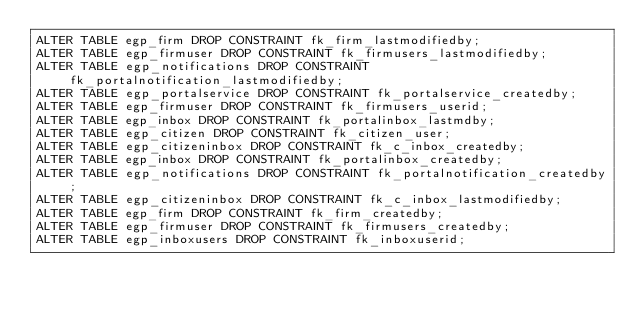Convert code to text. <code><loc_0><loc_0><loc_500><loc_500><_SQL_>ALTER TABLE egp_firm DROP CONSTRAINT fk_firm_lastmodifiedby;
ALTER TABLE egp_firmuser DROP CONSTRAINT fk_firmusers_lastmodifiedby;
ALTER TABLE egp_notifications DROP CONSTRAINT fk_portalnotification_lastmodifiedby;
ALTER TABLE egp_portalservice DROP CONSTRAINT fk_portalservice_createdby;
ALTER TABLE egp_firmuser DROP CONSTRAINT fk_firmusers_userid;
ALTER TABLE egp_inbox DROP CONSTRAINT fk_portalinbox_lastmdby;
ALTER TABLE egp_citizen DROP CONSTRAINT fk_citizen_user;
ALTER TABLE egp_citizeninbox DROP CONSTRAINT fk_c_inbox_createdby;
ALTER TABLE egp_inbox DROP CONSTRAINT fk_portalinbox_createdby;
ALTER TABLE egp_notifications DROP CONSTRAINT fk_portalnotification_createdby;
ALTER TABLE egp_citizeninbox DROP CONSTRAINT fk_c_inbox_lastmodifiedby;
ALTER TABLE egp_firm DROP CONSTRAINT fk_firm_createdby;
ALTER TABLE egp_firmuser DROP CONSTRAINT fk_firmusers_createdby;
ALTER TABLE egp_inboxusers DROP CONSTRAINT fk_inboxuserid;</code> 